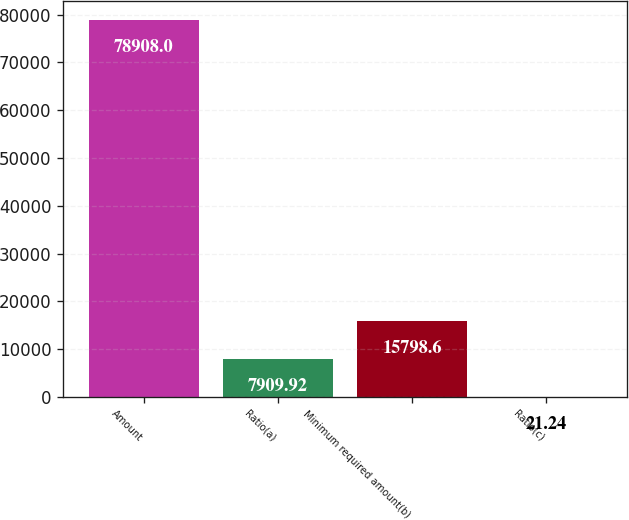<chart> <loc_0><loc_0><loc_500><loc_500><bar_chart><fcel>Amount<fcel>Ratio(a)<fcel>Minimum required amount(b)<fcel>Ratio(c)<nl><fcel>78908<fcel>7909.92<fcel>15798.6<fcel>21.24<nl></chart> 